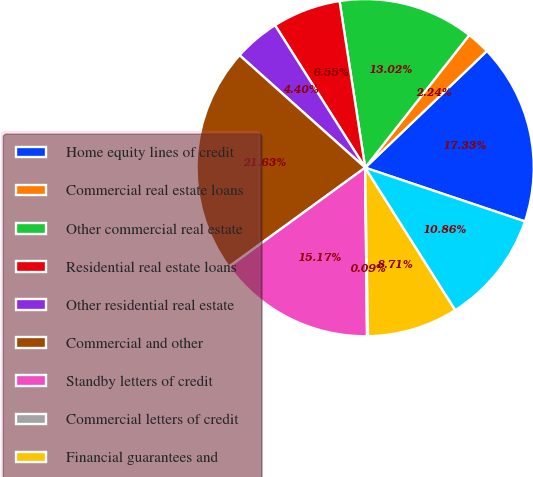<chart> <loc_0><loc_0><loc_500><loc_500><pie_chart><fcel>Home equity lines of credit<fcel>Commercial real estate loans<fcel>Other commercial real estate<fcel>Residential real estate loans<fcel>Other residential real estate<fcel>Commercial and other<fcel>Standby letters of credit<fcel>Commercial letters of credit<fcel>Financial guarantees and<fcel>Commitments to sell real<nl><fcel>17.33%<fcel>2.24%<fcel>13.02%<fcel>6.55%<fcel>4.4%<fcel>21.63%<fcel>15.17%<fcel>0.09%<fcel>8.71%<fcel>10.86%<nl></chart> 